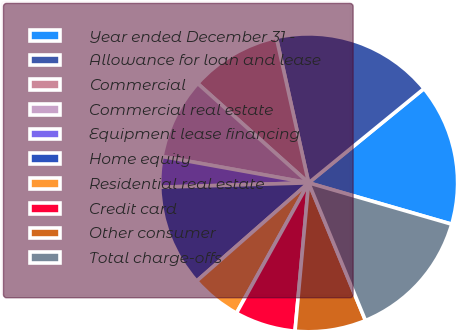<chart> <loc_0><loc_0><loc_500><loc_500><pie_chart><fcel>Year ended December 31 -<fcel>Allowance for loan and lease<fcel>Commercial<fcel>Commercial real estate<fcel>Equipment lease financing<fcel>Home equity<fcel>Residential real estate<fcel>Credit card<fcel>Other consumer<fcel>Total charge-offs<nl><fcel>15.38%<fcel>17.58%<fcel>9.89%<fcel>8.79%<fcel>3.3%<fcel>10.99%<fcel>5.49%<fcel>6.59%<fcel>7.69%<fcel>14.29%<nl></chart> 